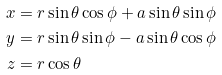Convert formula to latex. <formula><loc_0><loc_0><loc_500><loc_500>x & = r \sin \theta \cos \phi + a \sin \theta \sin \phi \\ y & = r \sin \theta \sin \phi - a \sin \theta \cos \phi \\ z & = r \cos \theta</formula> 